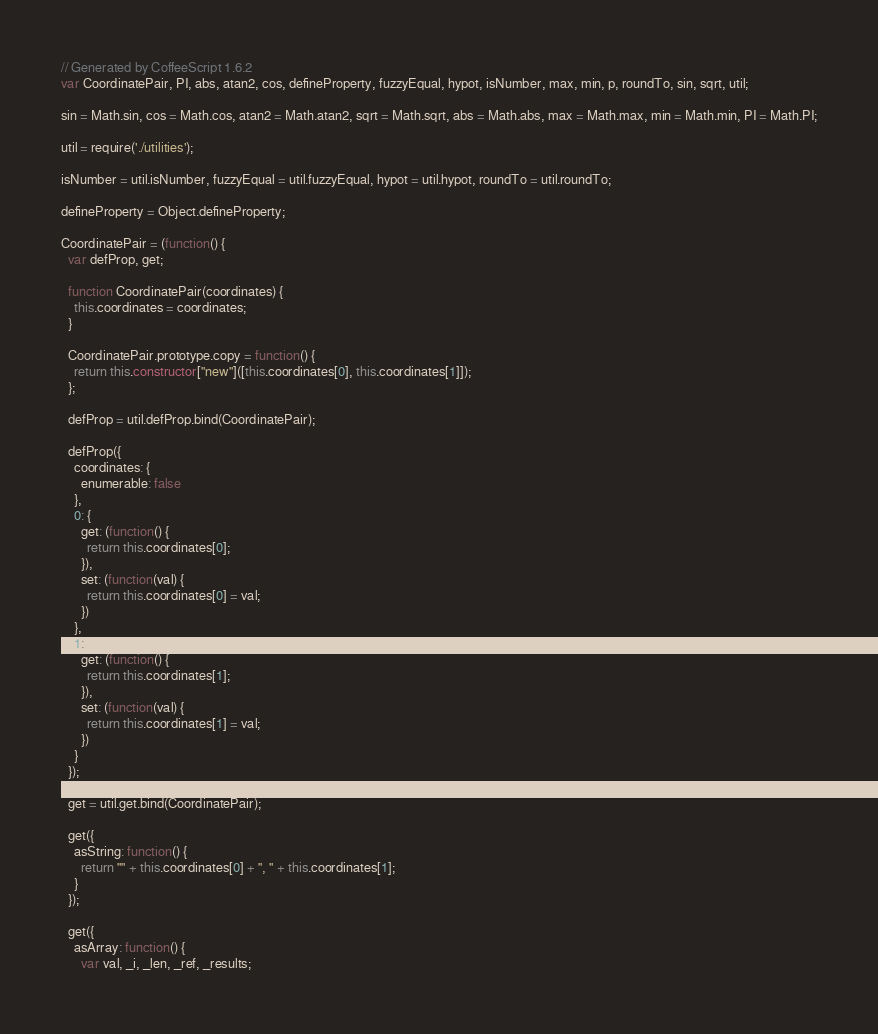<code> <loc_0><loc_0><loc_500><loc_500><_JavaScript_>// Generated by CoffeeScript 1.6.2
var CoordinatePair, PI, abs, atan2, cos, defineProperty, fuzzyEqual, hypot, isNumber, max, min, p, roundTo, sin, sqrt, util;

sin = Math.sin, cos = Math.cos, atan2 = Math.atan2, sqrt = Math.sqrt, abs = Math.abs, max = Math.max, min = Math.min, PI = Math.PI;

util = require('./utilities');

isNumber = util.isNumber, fuzzyEqual = util.fuzzyEqual, hypot = util.hypot, roundTo = util.roundTo;

defineProperty = Object.defineProperty;

CoordinatePair = (function() {
  var defProp, get;

  function CoordinatePair(coordinates) {
    this.coordinates = coordinates;
  }

  CoordinatePair.prototype.copy = function() {
    return this.constructor["new"]([this.coordinates[0], this.coordinates[1]]);
  };

  defProp = util.defProp.bind(CoordinatePair);

  defProp({
    coordinates: {
      enumerable: false
    },
    0: {
      get: (function() {
        return this.coordinates[0];
      }),
      set: (function(val) {
        return this.coordinates[0] = val;
      })
    },
    1: {
      get: (function() {
        return this.coordinates[1];
      }),
      set: (function(val) {
        return this.coordinates[1] = val;
      })
    }
  });

  get = util.get.bind(CoordinatePair);

  get({
    asString: function() {
      return "" + this.coordinates[0] + ", " + this.coordinates[1];
    }
  });

  get({
    asArray: function() {
      var val, _i, _len, _ref, _results;
</code> 